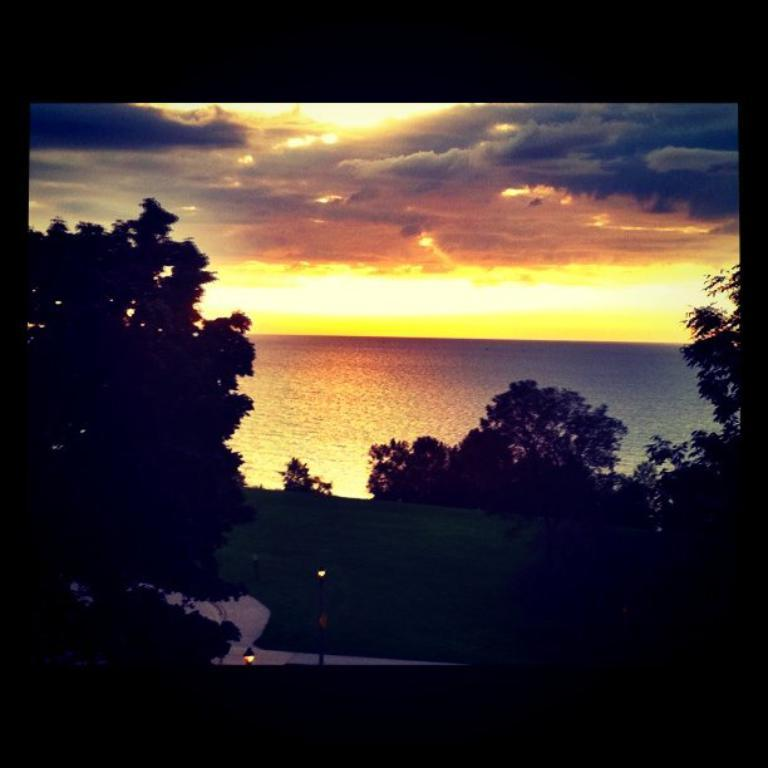What is located in the center of the image? There are trees in the center of the image. What can be seen at the bottom of the image? There is a walkway and grass at the bottom of the image. What is visible in the background of the image? There is a river in the background of the image. What is visible at the top of the image? The sky is visible at the top of the image. Can you see any veins in the trees in the image? There are no veins visible in the trees in the image. Is there a note attached to one of the trees in the image? There is no note attached to any of the trees in the image. 